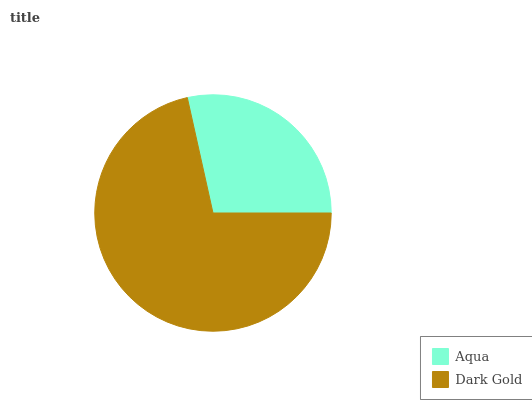Is Aqua the minimum?
Answer yes or no. Yes. Is Dark Gold the maximum?
Answer yes or no. Yes. Is Dark Gold the minimum?
Answer yes or no. No. Is Dark Gold greater than Aqua?
Answer yes or no. Yes. Is Aqua less than Dark Gold?
Answer yes or no. Yes. Is Aqua greater than Dark Gold?
Answer yes or no. No. Is Dark Gold less than Aqua?
Answer yes or no. No. Is Dark Gold the high median?
Answer yes or no. Yes. Is Aqua the low median?
Answer yes or no. Yes. Is Aqua the high median?
Answer yes or no. No. Is Dark Gold the low median?
Answer yes or no. No. 